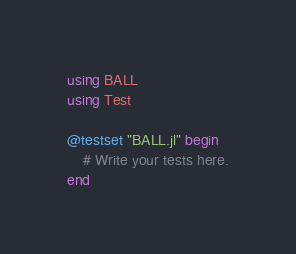Convert code to text. <code><loc_0><loc_0><loc_500><loc_500><_Julia_>using BALL
using Test

@testset "BALL.jl" begin
    # Write your tests here.
end
</code> 